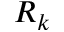<formula> <loc_0><loc_0><loc_500><loc_500>R _ { k }</formula> 